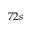<formula> <loc_0><loc_0><loc_500><loc_500>7 2 s</formula> 